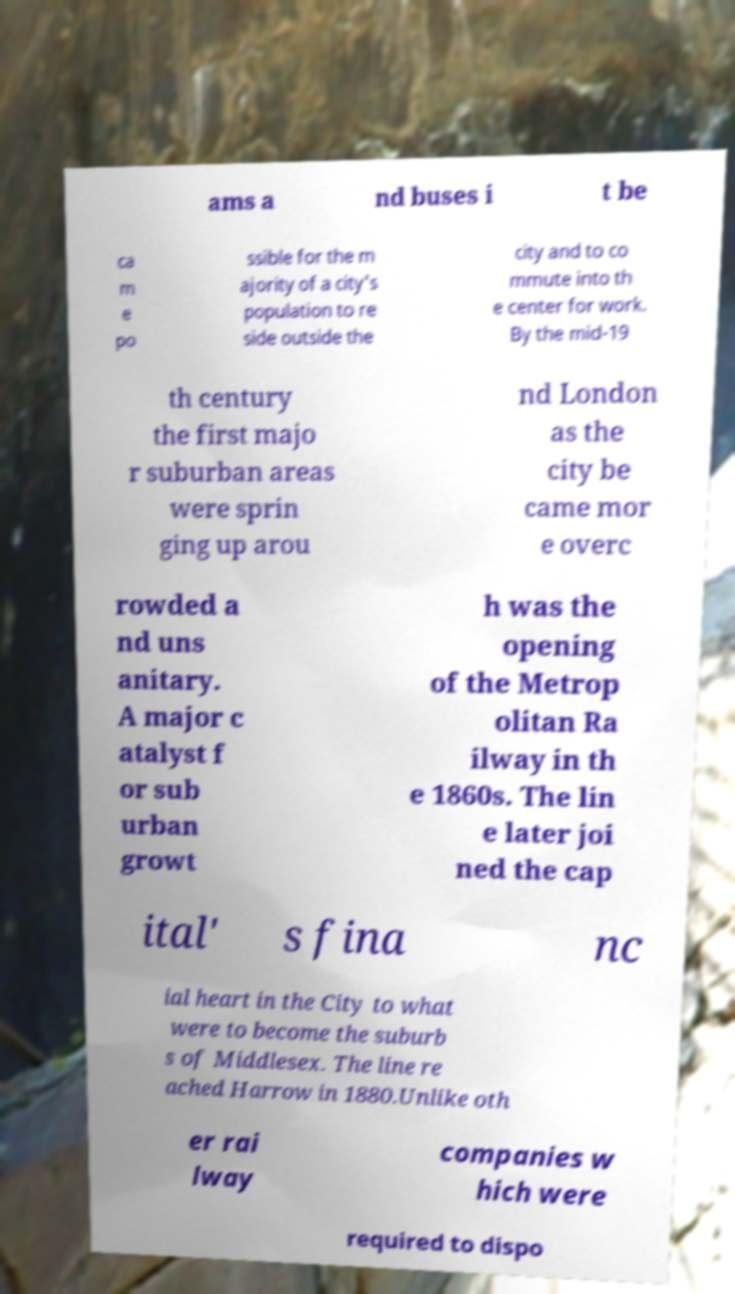I need the written content from this picture converted into text. Can you do that? ams a nd buses i t be ca m e po ssible for the m ajority of a city's population to re side outside the city and to co mmute into th e center for work. By the mid-19 th century the first majo r suburban areas were sprin ging up arou nd London as the city be came mor e overc rowded a nd uns anitary. A major c atalyst f or sub urban growt h was the opening of the Metrop olitan Ra ilway in th e 1860s. The lin e later joi ned the cap ital' s fina nc ial heart in the City to what were to become the suburb s of Middlesex. The line re ached Harrow in 1880.Unlike oth er rai lway companies w hich were required to dispo 